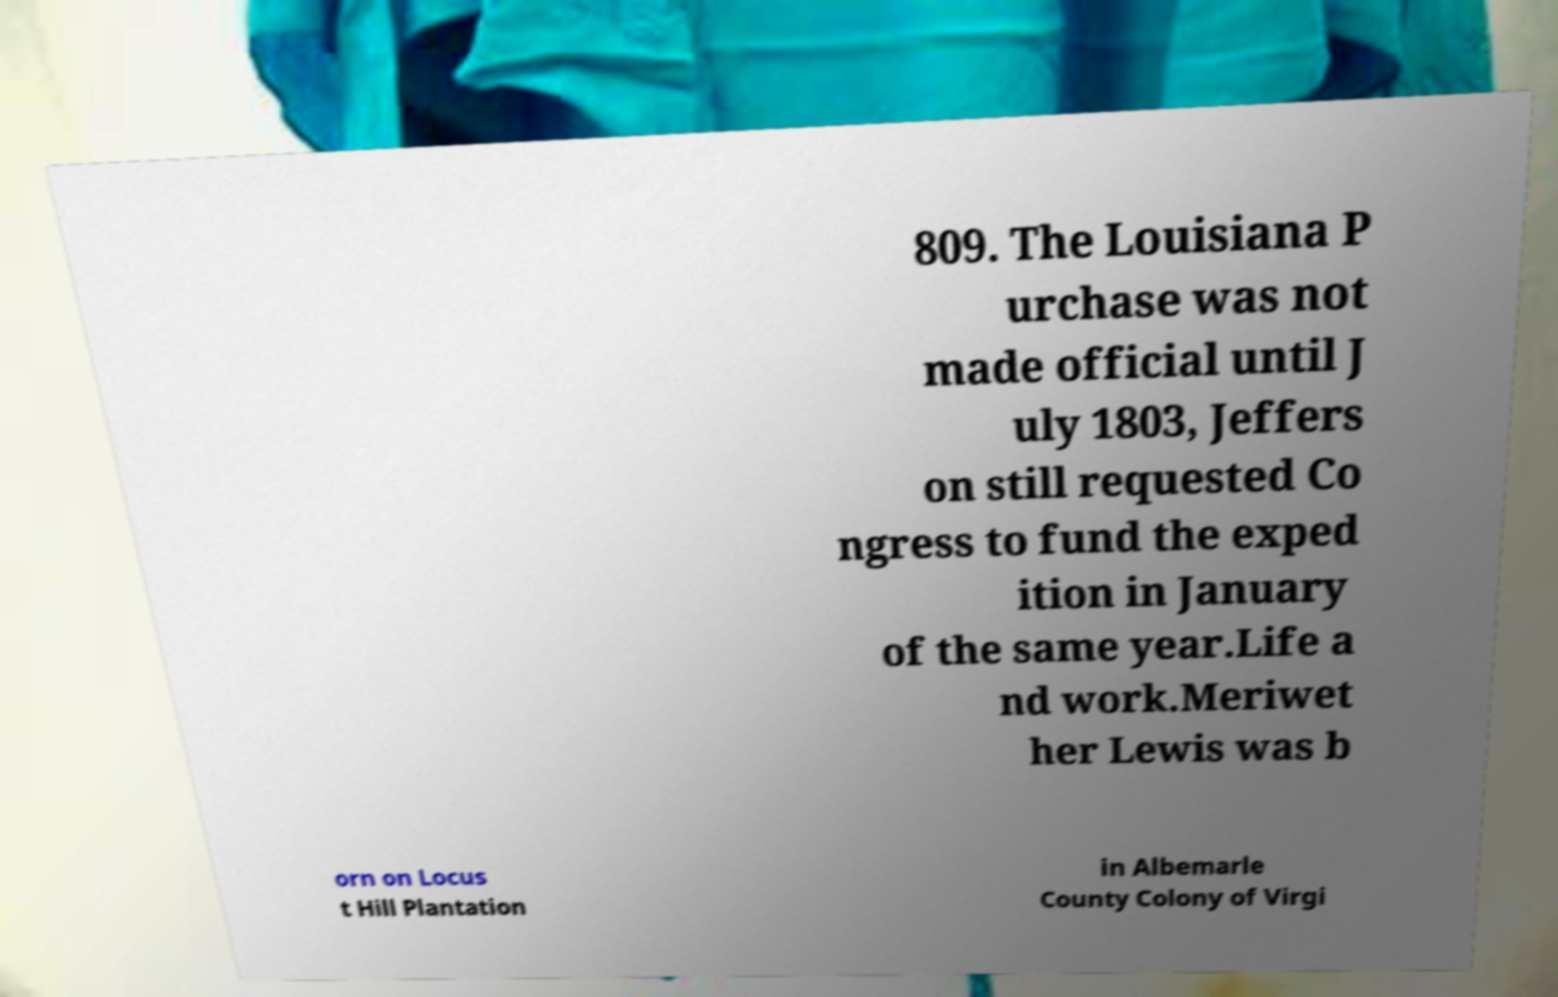I need the written content from this picture converted into text. Can you do that? 809. The Louisiana P urchase was not made official until J uly 1803, Jeffers on still requested Co ngress to fund the exped ition in January of the same year.Life a nd work.Meriwet her Lewis was b orn on Locus t Hill Plantation in Albemarle County Colony of Virgi 